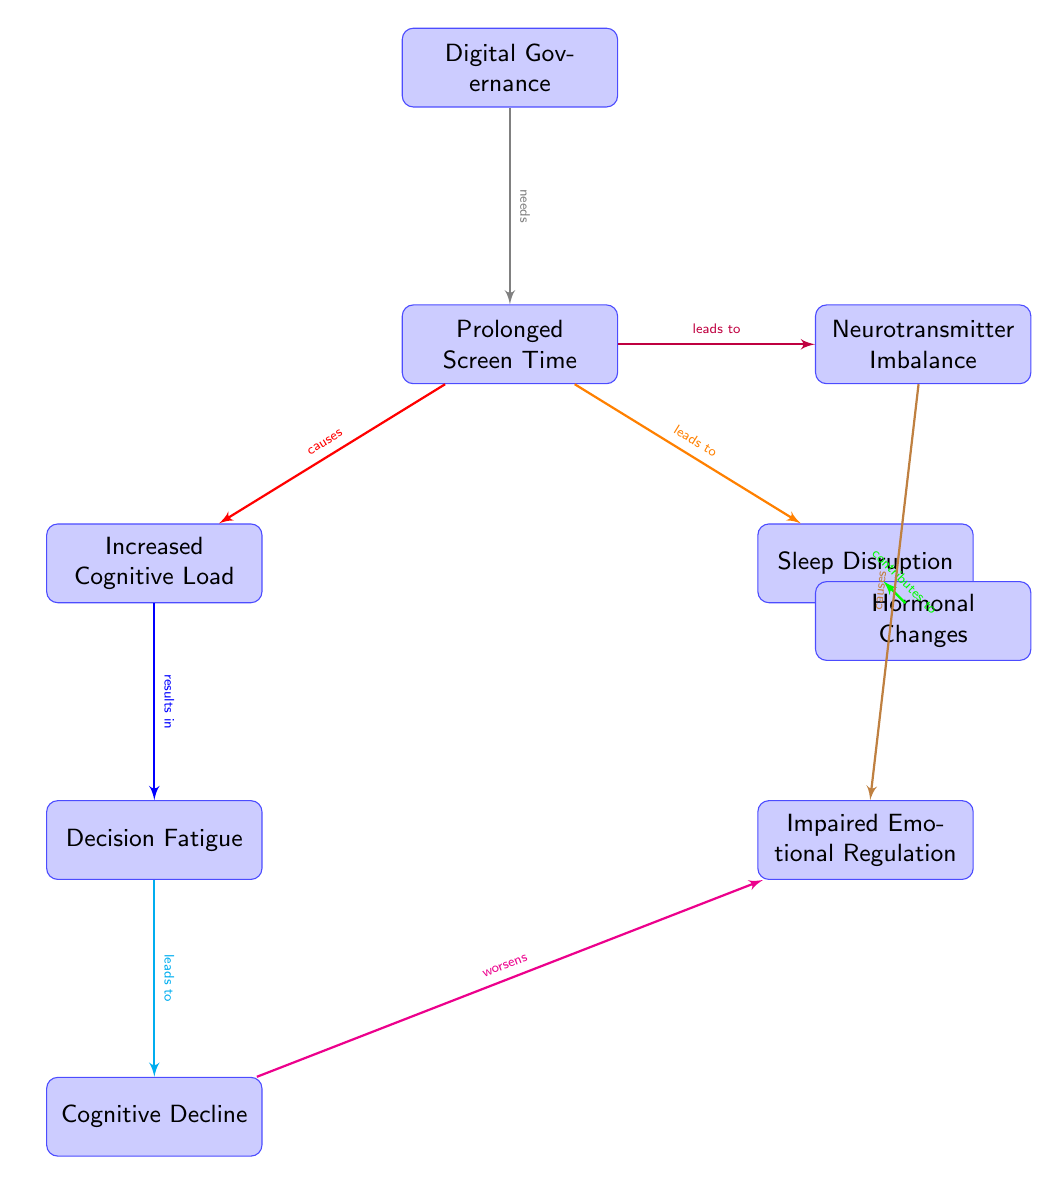What node is directly below "Prolonged Screen Time"? The node directly below "Prolonged Screen Time" is "Increased Cognitive Load" as per its position in the diagram.
Answer: Increased Cognitive Load How many nodes are connected to "Prolonged Screen Time"? "Prolonged Screen Time" has three nodes connected to it: "Increased Cognitive Load," "Sleep Disruption," and "Neurotransmitter Imbalance," which totals to three.
Answer: 3 What effect does "Sleep Disruption" lead to? "Sleep Disruption" contributes to "Hormonal Changes" as indicated by the directional edge in the diagram.
Answer: Hormonal Changes What nodes are affected by "Decision Fatigue"? "Decision Fatigue" leads to "Cognitive Decline," and it is also connected to "Impaired Emotional Regulation" indirectly through "Cognitive Decline." Therefore, it affects those two nodes.
Answer: Cognitive Decline, Impaired Emotional Regulation What causes "Impaired Emotional Regulation"? "Impaired Emotional Regulation" is caused by "Neurotransmitter Imbalance," as shown in the diagram with a directed edge indicating the causal relationship.
Answer: Neurotransmitter Imbalance What is the relationship between "Cognitive Load" and "Decision Fatigue"? "Cognitive Load" results in "Decision Fatigue," forming a cause-and-effect relationship as outlined in the diagram.
Answer: results in How does "Prolonged Screen Time" relate to "Digital Governance"? "Digital Governance" needs "Prolonged Screen Time," indicating an essential relationship where digital governance relies on screen time, as per the diagram.
Answer: needs Which condition worsens due to "Cognitive Decline"? "Cognitive Decline" worsens "Impaired Emotional Regulation," indicating that cognitive decline exacerbates emotional issues as indicated by the directional edge.
Answer: Impaired Emotional Regulation What is an effect of "Increased Cognitive Load"? "Increased Cognitive Load" results in "Decision Fatigue," which shows a step of impact from cognitive load to fatigue in decision-making processes, as depicted in the diagram.
Answer: Decision Fatigue 